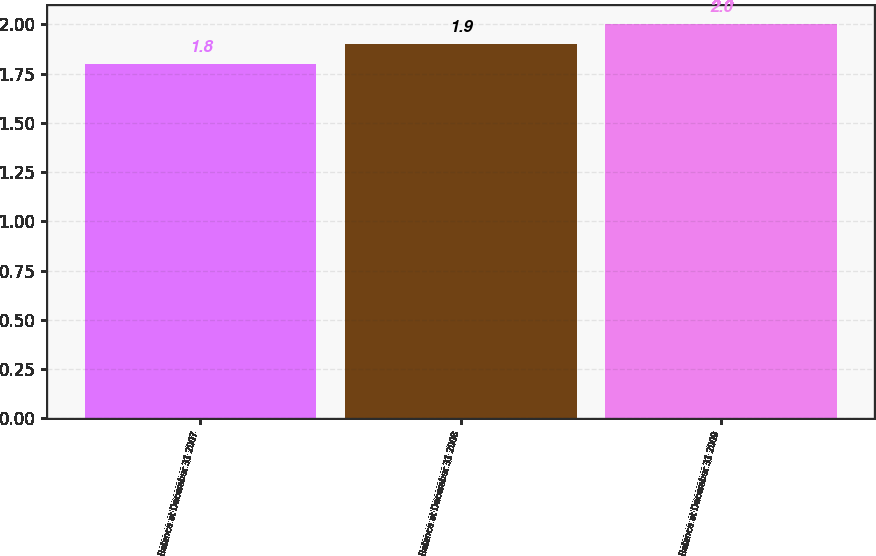<chart> <loc_0><loc_0><loc_500><loc_500><bar_chart><fcel>Balance at December 31 2007<fcel>Balance at December 31 2008<fcel>Balance at December 31 2009<nl><fcel>1.8<fcel>1.9<fcel>2<nl></chart> 